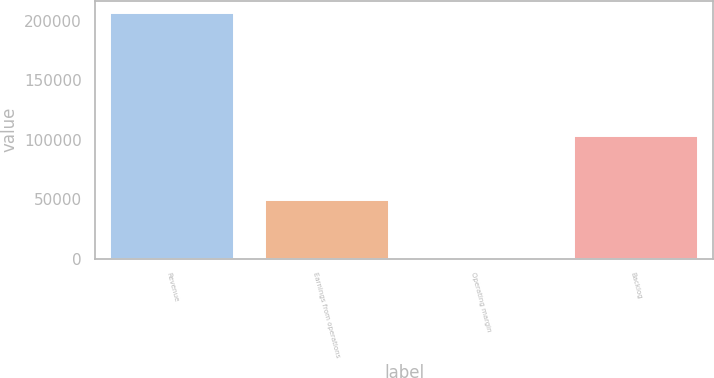Convert chart to OTSL. <chart><loc_0><loc_0><loc_500><loc_500><bar_chart><fcel>Revenue<fcel>Earnings from operations<fcel>Operating margin<fcel>Backlog<nl><fcel>206323<fcel>49322<fcel>23.9<fcel>103000<nl></chart> 